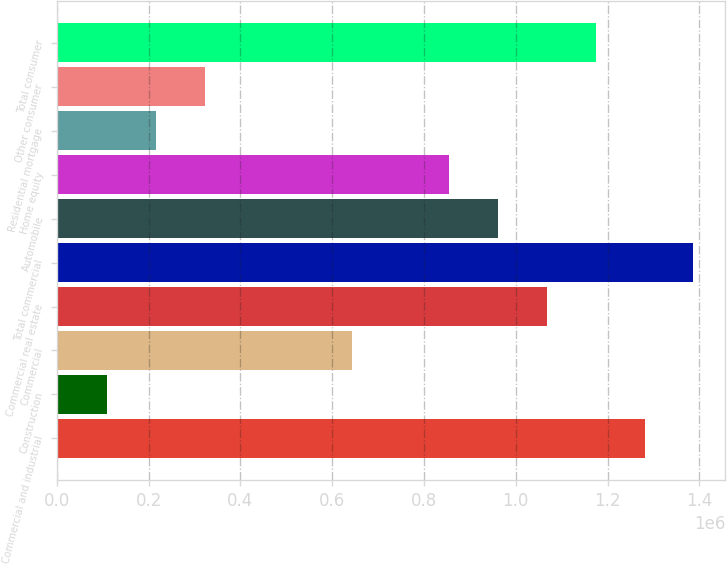<chart> <loc_0><loc_0><loc_500><loc_500><bar_chart><fcel>Commercial and industrial<fcel>Construction<fcel>Commercial<fcel>Commercial real estate<fcel>Total commercial<fcel>Automobile<fcel>Home equity<fcel>Residential mortgage<fcel>Other consumer<fcel>Total consumer<nl><fcel>1.28066e+06<fcel>109889<fcel>642056<fcel>1.06779e+06<fcel>1.38709e+06<fcel>961356<fcel>854922<fcel>216323<fcel>322756<fcel>1.17422e+06<nl></chart> 